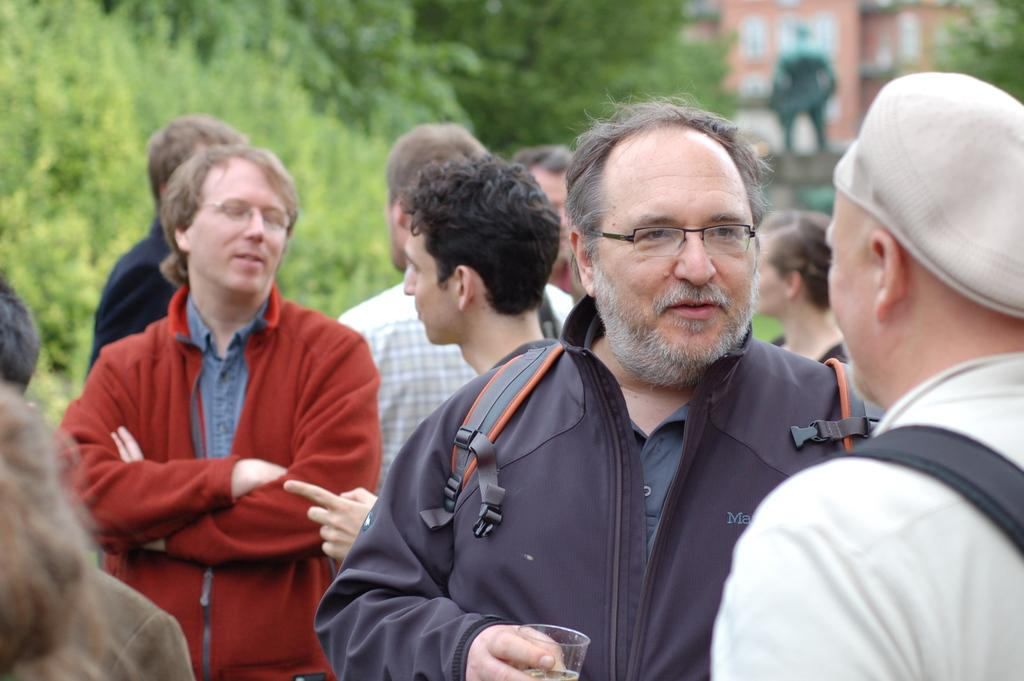How many people are present in the image? There are many persons standing on the ground in the image. What can be seen in the background of the image? There are trees, a statue, and a building in the background of the image. What is the rate at which the trains are passing by in the image? There are no trains present in the image, so it is not possible to determine the rate at which they might be passing by. 